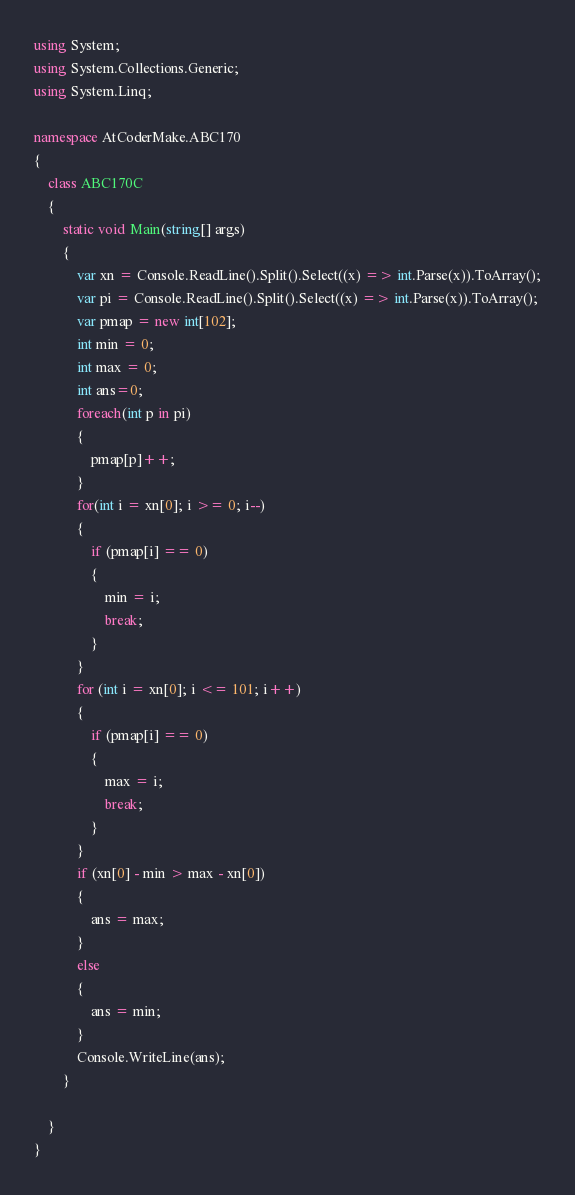Convert code to text. <code><loc_0><loc_0><loc_500><loc_500><_C#_>using System;
using System.Collections.Generic;
using System.Linq;

namespace AtCoderMake.ABC170
{
    class ABC170C
    {
        static void Main(string[] args)
        {
            var xn = Console.ReadLine().Split().Select((x) => int.Parse(x)).ToArray();
            var pi = Console.ReadLine().Split().Select((x) => int.Parse(x)).ToArray();
            var pmap = new int[102];
            int min = 0;
            int max = 0;
            int ans=0;
            foreach(int p in pi)
            {
                pmap[p]++;
            }
            for(int i = xn[0]; i >= 0; i--)
            {
                if (pmap[i] == 0)
                {
                    min = i;
                    break;
                }
            }
            for (int i = xn[0]; i <= 101; i++)
            {
                if (pmap[i] == 0)
                {
                    max = i;
                    break;
                }
            }
            if (xn[0] - min > max - xn[0])
            {
                ans = max;
            }
            else
            {
                ans = min;
            }
            Console.WriteLine(ans);
        }
        
    }
}
</code> 